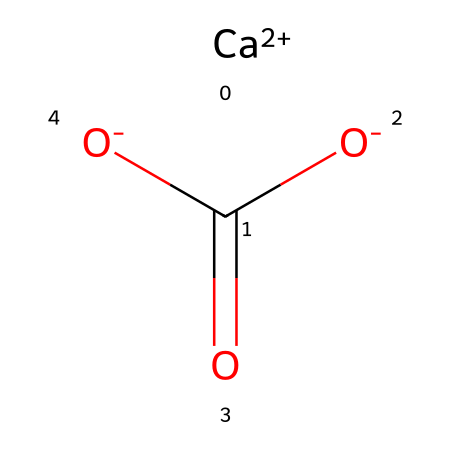What is the chemical name of this compound? The SMILES representation indicates a combination of calcium (Ca), carbon (C), and oxygen (O), which is commonly known as calcium carbonate.
Answer: calcium carbonate How many oxygen atoms are present in this structure? By looking at the SMILES representation, there are three "O" atoms indicated, which represents the three oxygen atoms in calcium carbonate.
Answer: three Does this chemical contain any acidic properties? Calcium carbonate is classified as a base, and it can neutralize acids, indicating it possesses no acidic properties.
Answer: no What ions does calcium carbonate release when dissolved in water? The dissociation of calcium carbonate in water produces calcium ions and bicarbonate ions, confirming that it releases these ions.
Answer: calcium ions and bicarbonate ions What role does calcium carbonate have in antacids? Calcium carbonate acts primarily as an acid neutralizer in antacid formulations, providing relief from heartburn and indigestion.
Answer: acid neutralizer How does the structure of calcium carbonate influence its effectiveness as an antacid? The presence of carbonate ions allows calcium carbonate to react with stomach acids, promoting its effectiveness as an antacid to relieve discomfort.
Answer: reacts with stomach acids 